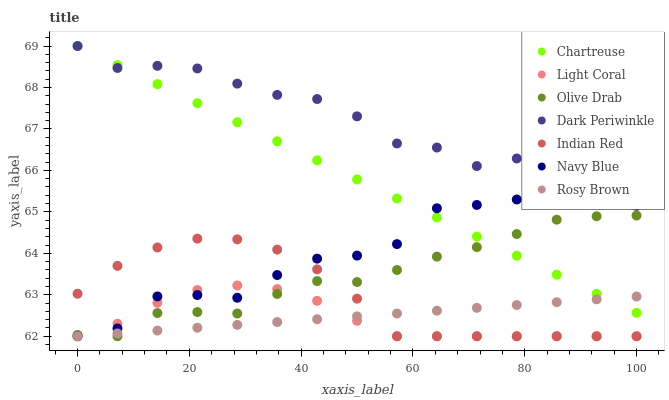Does Light Coral have the minimum area under the curve?
Answer yes or no. Yes. Does Dark Periwinkle have the maximum area under the curve?
Answer yes or no. Yes. Does Rosy Brown have the minimum area under the curve?
Answer yes or no. No. Does Rosy Brown have the maximum area under the curve?
Answer yes or no. No. Is Rosy Brown the smoothest?
Answer yes or no. Yes. Is Navy Blue the roughest?
Answer yes or no. Yes. Is Light Coral the smoothest?
Answer yes or no. No. Is Light Coral the roughest?
Answer yes or no. No. Does Navy Blue have the lowest value?
Answer yes or no. Yes. Does Chartreuse have the lowest value?
Answer yes or no. No. Does Dark Periwinkle have the highest value?
Answer yes or no. Yes. Does Light Coral have the highest value?
Answer yes or no. No. Is Olive Drab less than Dark Periwinkle?
Answer yes or no. Yes. Is Dark Periwinkle greater than Olive Drab?
Answer yes or no. Yes. Does Light Coral intersect Olive Drab?
Answer yes or no. Yes. Is Light Coral less than Olive Drab?
Answer yes or no. No. Is Light Coral greater than Olive Drab?
Answer yes or no. No. Does Olive Drab intersect Dark Periwinkle?
Answer yes or no. No. 